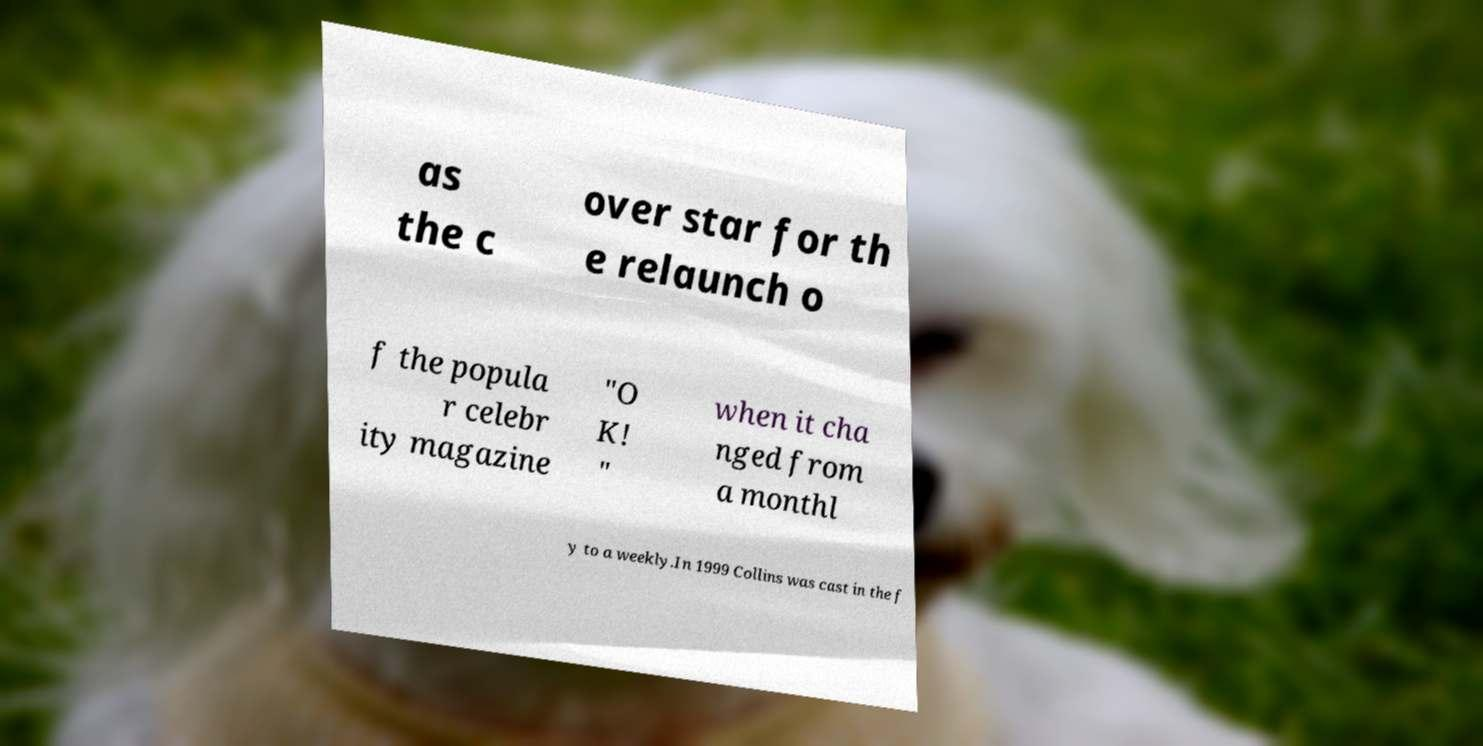Can you read and provide the text displayed in the image?This photo seems to have some interesting text. Can you extract and type it out for me? as the c over star for th e relaunch o f the popula r celebr ity magazine "O K! " when it cha nged from a monthl y to a weekly.In 1999 Collins was cast in the f 